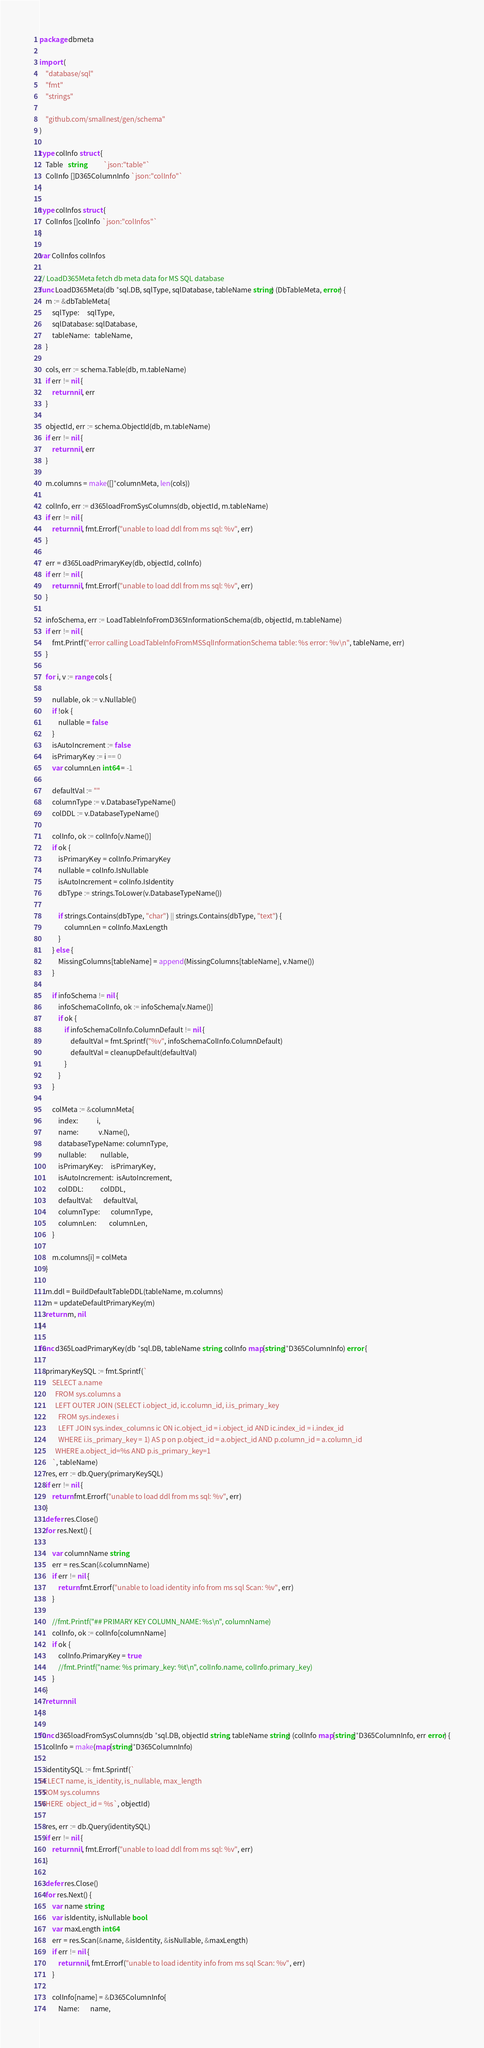Convert code to text. <code><loc_0><loc_0><loc_500><loc_500><_Go_>package dbmeta

import (
	"database/sql"
	"fmt"
	"strings"

	"github.com/smallnest/gen/schema"
)

type colInfo struct {
	Table   string           `json:"table"`
	ColInfo []D365ColumnInfo `json:"colInfo"`
}

type colInfos struct {
	ColInfos []colInfo `json:"colInfos"`
}

var ColInfos colInfos

// LoadD365Meta fetch db meta data for MS SQL database
func LoadD365Meta(db *sql.DB, sqlType, sqlDatabase, tableName string) (DbTableMeta, error) {
	m := &dbTableMeta{
		sqlType:     sqlType,
		sqlDatabase: sqlDatabase,
		tableName:   tableName,
	}

	cols, err := schema.Table(db, m.tableName)
	if err != nil {
		return nil, err
	}

	objectId, err := schema.ObjectId(db, m.tableName)
	if err != nil {
		return nil, err
	}

	m.columns = make([]*columnMeta, len(cols))

	colInfo, err := d365loadFromSysColumns(db, objectId, m.tableName)
	if err != nil {
		return nil, fmt.Errorf("unable to load ddl from ms sql: %v", err)
	}

	err = d365LoadPrimaryKey(db, objectId, colInfo)
	if err != nil {
		return nil, fmt.Errorf("unable to load ddl from ms sql: %v", err)
	}

	infoSchema, err := LoadTableInfoFromD365InformationSchema(db, objectId, m.tableName)
	if err != nil {
		fmt.Printf("error calling LoadTableInfoFromMSSqlInformationSchema table: %s error: %v\n", tableName, err)
	}

	for i, v := range cols {

		nullable, ok := v.Nullable()
		if !ok {
			nullable = false
		}
		isAutoIncrement := false
		isPrimaryKey := i == 0
		var columnLen int64 = -1

		defaultVal := ""
		columnType := v.DatabaseTypeName()
		colDDL := v.DatabaseTypeName()

		colInfo, ok := colInfo[v.Name()]
		if ok {
			isPrimaryKey = colInfo.PrimaryKey
			nullable = colInfo.IsNullable
			isAutoIncrement = colInfo.IsIdentity
			dbType := strings.ToLower(v.DatabaseTypeName())

			if strings.Contains(dbType, "char") || strings.Contains(dbType, "text") {
				columnLen = colInfo.MaxLength
			}
		} else {
			MissingColumns[tableName] = append(MissingColumns[tableName], v.Name())
		}

		if infoSchema != nil {
			infoSchemaColInfo, ok := infoSchema[v.Name()]
			if ok {
				if infoSchemaColInfo.ColumnDefault != nil {
					defaultVal = fmt.Sprintf("%v", infoSchemaColInfo.ColumnDefault)
					defaultVal = cleanupDefault(defaultVal)
				}
			}
		}

		colMeta := &columnMeta{
			index:            i,
			name:             v.Name(),
			databaseTypeName: columnType,
			nullable:         nullable,
			isPrimaryKey:     isPrimaryKey,
			isAutoIncrement:  isAutoIncrement,
			colDDL:           colDDL,
			defaultVal:       defaultVal,
			columnType:       columnType,
			columnLen:        columnLen,
		}

		m.columns[i] = colMeta
	}

	m.ddl = BuildDefaultTableDDL(tableName, m.columns)
	m = updateDefaultPrimaryKey(m)
	return m, nil
}

func d365LoadPrimaryKey(db *sql.DB, tableName string, colInfo map[string]*D365ColumnInfo) error {

	primaryKeySQL := fmt.Sprintf(`
		SELECT a.name
          FROM sys.columns a 
		  LEFT OUTER JOIN (SELECT i.object_id, ic.column_id, i.is_primary_key
			FROM sys.indexes i
		  	LEFT JOIN sys.index_columns ic ON ic.object_id = i.object_id AND ic.index_id = i.index_id
			WHERE i.is_primary_key = 1) AS p on p.object_id = a.object_id AND p.column_id = a.column_id
          WHERE a.object_id=%s AND p.is_primary_key=1
		`, tableName)
	res, err := db.Query(primaryKeySQL)
	if err != nil {
		return fmt.Errorf("unable to load ddl from ms sql: %v", err)
	}
	defer res.Close()
	for res.Next() {

		var columnName string
		err = res.Scan(&columnName)
		if err != nil {
			return fmt.Errorf("unable to load identity info from ms sql Scan: %v", err)
		}

		//fmt.Printf("## PRIMARY KEY COLUMN_NAME: %s\n", columnName)
		colInfo, ok := colInfo[columnName]
		if ok {
			colInfo.PrimaryKey = true
			//fmt.Printf("name: %s primary_key: %t\n", colInfo.name, colInfo.primary_key)
		}
	}
	return nil
}

func d365loadFromSysColumns(db *sql.DB, objectId string, tableName string) (colInfo map[string]*D365ColumnInfo, err error) {
	colInfo = make(map[string]*D365ColumnInfo)

	identitySQL := fmt.Sprintf(`
SELECT name, is_identity, is_nullable, max_length 
FROM sys.columns 
WHERE  object_id = %s`, objectId)

	res, err := db.Query(identitySQL)
	if err != nil {
		return nil, fmt.Errorf("unable to load ddl from ms sql: %v", err)
	}

	defer res.Close()
	for res.Next() {
		var name string
		var isIdentity, isNullable bool
		var maxLength int64
		err = res.Scan(&name, &isIdentity, &isNullable, &maxLength)
		if err != nil {
			return nil, fmt.Errorf("unable to load identity info from ms sql Scan: %v", err)
		}

		colInfo[name] = &D365ColumnInfo{
			Name:       name,</code> 